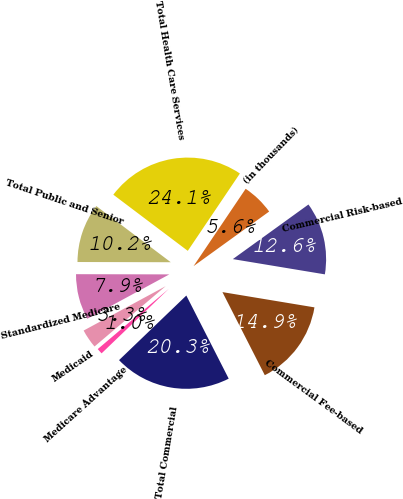Convert chart to OTSL. <chart><loc_0><loc_0><loc_500><loc_500><pie_chart><fcel>(in thousands)<fcel>Commercial Risk-based<fcel>Commercial Fee-based<fcel>Total Commercial<fcel>Medicare Advantage<fcel>Medicaid<fcel>Standardized Medicare<fcel>Total Public and Senior<fcel>Total Health Care Services<nl><fcel>5.61%<fcel>12.57%<fcel>14.88%<fcel>20.33%<fcel>0.98%<fcel>3.3%<fcel>7.93%<fcel>10.25%<fcel>24.15%<nl></chart> 